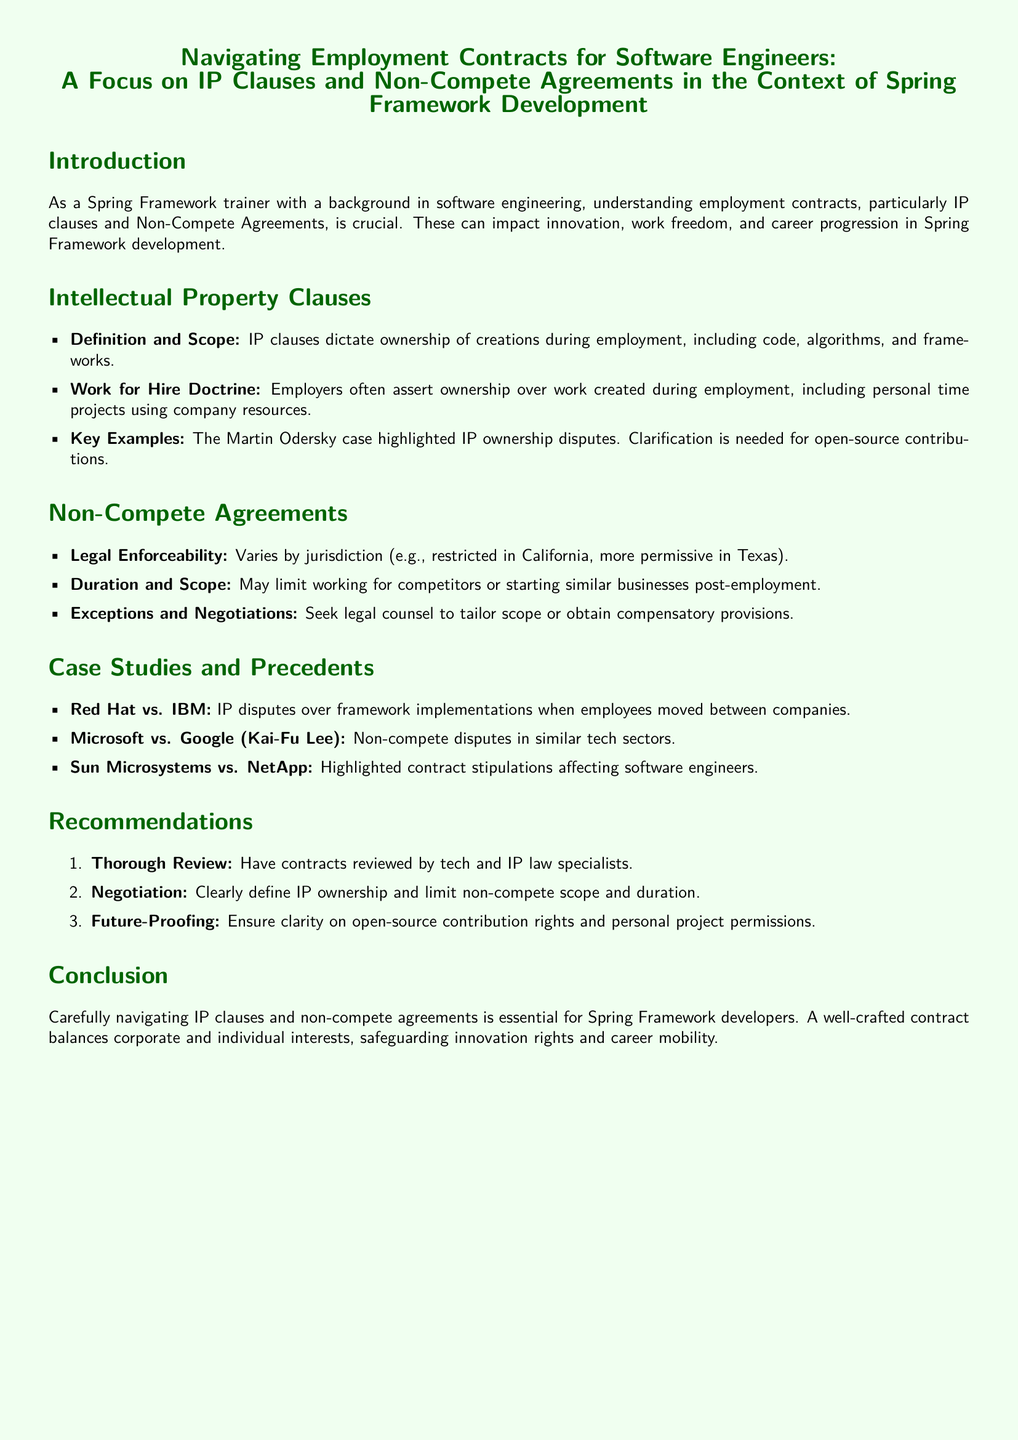What is the main focus of the document? The document focuses on navigating employment contracts with a special emphasis on IP clauses and non-compete agreements.
Answer: IP clauses and non-compete agreements What does the IP clause dictate? The IP clause dictates ownership of creations during employment, including code and algorithms.
Answer: Ownership of creations In which case were IP ownership disputes highlighted? The Martin Odersky case highlighted disputes related to IP ownership.
Answer: Martin Odersky Which company is restricted by non-compete laws in its jurisdiction? California is known for having restrictions on non-compete agreements.
Answer: California What is a recommended step before signing a contract? A thorough review of contracts by specialists in tech and IP law is recommended.
Answer: Thorough review What is the legal enforceability of non-compete agreements? The legal enforceability of non-compete agreements varies by jurisdiction.
Answer: Varies by jurisdiction Which case involved non-compete disputes in the tech sector? The Microsoft vs. Google case involved non-compete disputes.
Answer: Microsoft vs. Google What is one exception to non-compete negotiation suggestions? Seek legal counsel to tailor the scope of non-compete agreements.
Answer: Seek legal counsel What does the document suggest about future-proofing? The document suggests ensuring clarity on open-source contribution rights.
Answer: Clarity on open-source rights 